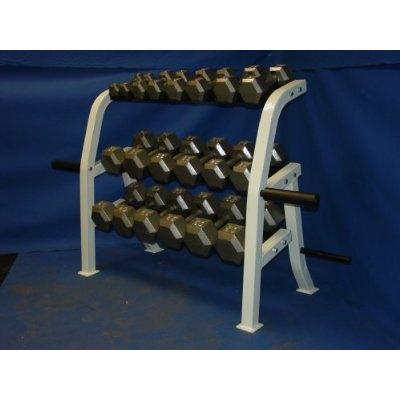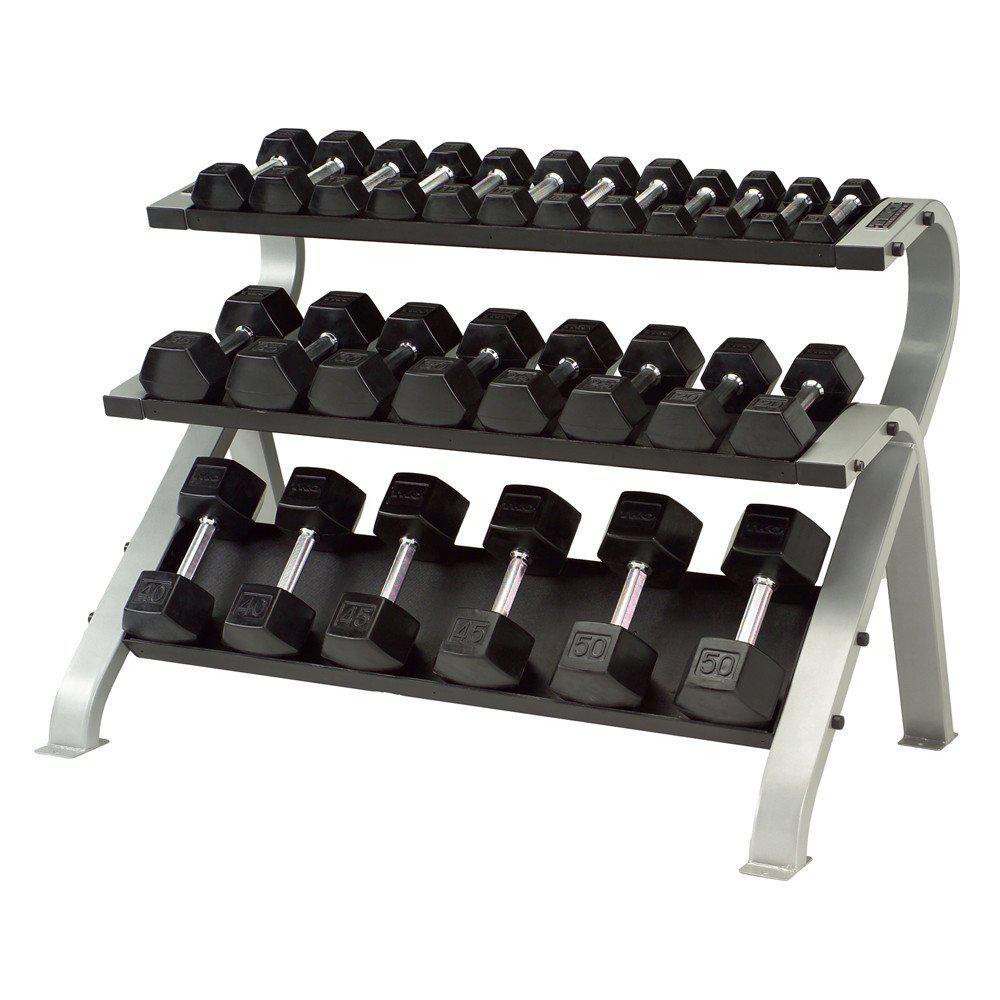The first image is the image on the left, the second image is the image on the right. Considering the images on both sides, is "The right image contains sets of weights stacked into three rows." valid? Answer yes or no. Yes. The first image is the image on the left, the second image is the image on the right. Considering the images on both sides, is "The weights on the rack in the image on the left are round." valid? Answer yes or no. No. 